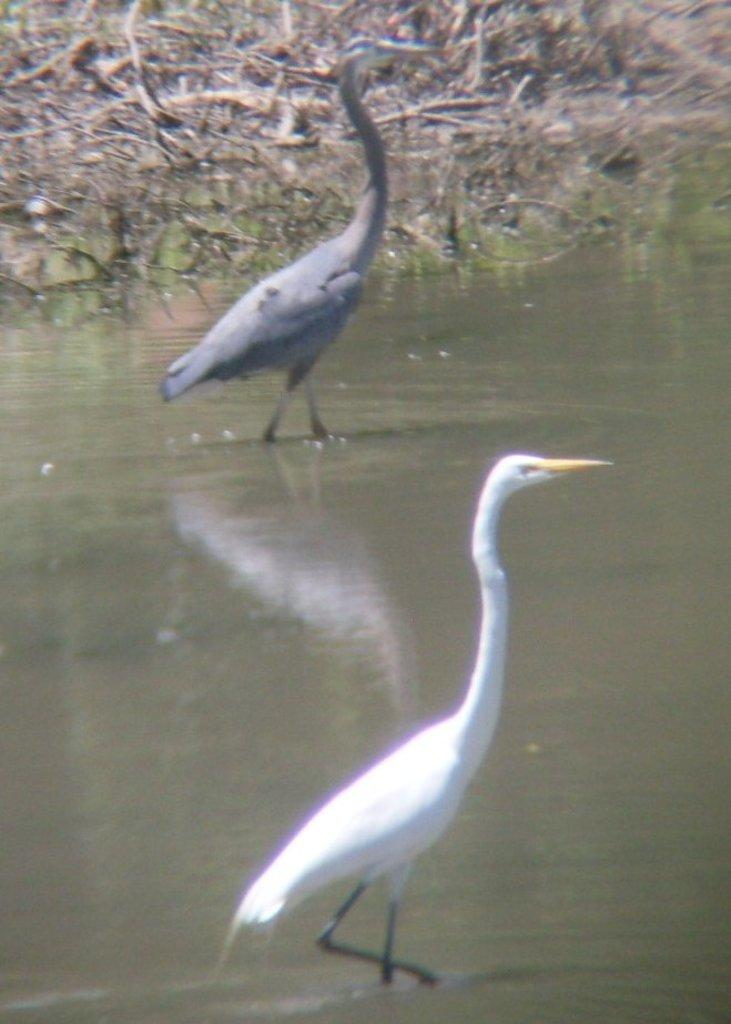How many boats can be seen in the image? There are two boats in the image. Where are the boats located? The boats are on the surface of the water. What else can be seen in the image besides the boats? There are fallen branches of trees visible in the image. What type of produce is being harvested by the mother in the image? There is no mother or produce present in the image; it features two boats on the water and fallen branches of trees. 